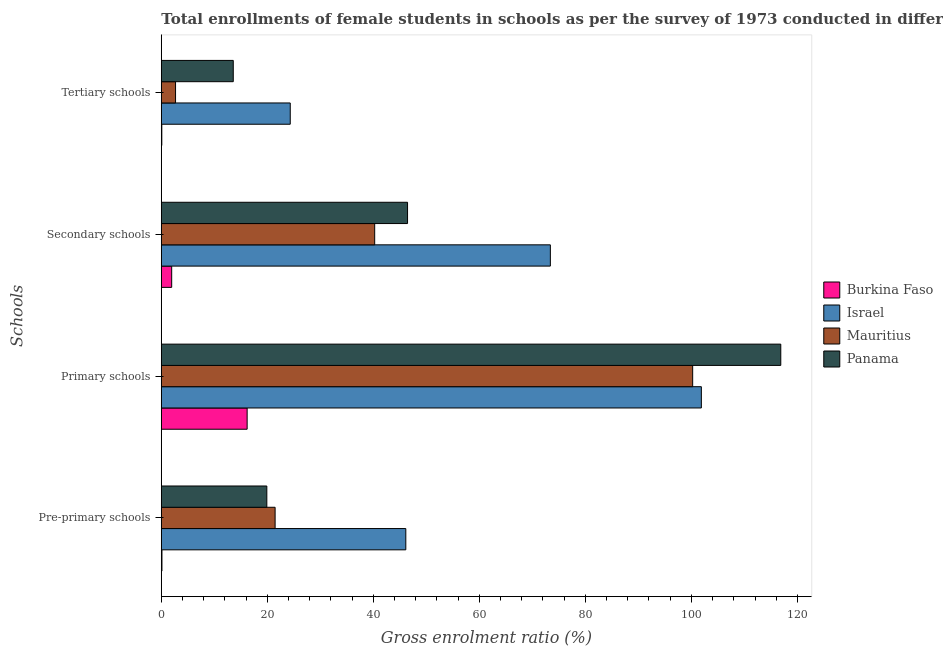How many different coloured bars are there?
Your answer should be very brief. 4. How many bars are there on the 2nd tick from the top?
Your answer should be very brief. 4. What is the label of the 2nd group of bars from the top?
Keep it short and to the point. Secondary schools. What is the gross enrolment ratio(female) in secondary schools in Mauritius?
Your answer should be compact. 40.25. Across all countries, what is the maximum gross enrolment ratio(female) in pre-primary schools?
Provide a succinct answer. 46.12. Across all countries, what is the minimum gross enrolment ratio(female) in secondary schools?
Provide a succinct answer. 1.96. In which country was the gross enrolment ratio(female) in tertiary schools minimum?
Ensure brevity in your answer.  Burkina Faso. What is the total gross enrolment ratio(female) in primary schools in the graph?
Give a very brief answer. 335.17. What is the difference between the gross enrolment ratio(female) in pre-primary schools in Burkina Faso and that in Panama?
Give a very brief answer. -19.79. What is the difference between the gross enrolment ratio(female) in tertiary schools in Panama and the gross enrolment ratio(female) in primary schools in Mauritius?
Offer a terse response. -86.67. What is the average gross enrolment ratio(female) in pre-primary schools per country?
Your answer should be compact. 21.9. What is the difference between the gross enrolment ratio(female) in pre-primary schools and gross enrolment ratio(female) in tertiary schools in Israel?
Provide a succinct answer. 21.8. What is the ratio of the gross enrolment ratio(female) in tertiary schools in Mauritius to that in Israel?
Make the answer very short. 0.11. Is the gross enrolment ratio(female) in pre-primary schools in Panama less than that in Burkina Faso?
Provide a succinct answer. No. What is the difference between the highest and the second highest gross enrolment ratio(female) in tertiary schools?
Offer a very short reply. 10.75. What is the difference between the highest and the lowest gross enrolment ratio(female) in primary schools?
Keep it short and to the point. 100.67. In how many countries, is the gross enrolment ratio(female) in pre-primary schools greater than the average gross enrolment ratio(female) in pre-primary schools taken over all countries?
Offer a terse response. 1. Is the sum of the gross enrolment ratio(female) in tertiary schools in Israel and Mauritius greater than the maximum gross enrolment ratio(female) in pre-primary schools across all countries?
Your response must be concise. No. Is it the case that in every country, the sum of the gross enrolment ratio(female) in pre-primary schools and gross enrolment ratio(female) in primary schools is greater than the sum of gross enrolment ratio(female) in secondary schools and gross enrolment ratio(female) in tertiary schools?
Give a very brief answer. No. What does the 2nd bar from the top in Primary schools represents?
Provide a succinct answer. Mauritius. What does the 3rd bar from the bottom in Tertiary schools represents?
Provide a short and direct response. Mauritius. Is it the case that in every country, the sum of the gross enrolment ratio(female) in pre-primary schools and gross enrolment ratio(female) in primary schools is greater than the gross enrolment ratio(female) in secondary schools?
Ensure brevity in your answer.  Yes. Are all the bars in the graph horizontal?
Provide a short and direct response. Yes. How many countries are there in the graph?
Provide a short and direct response. 4. What is the difference between two consecutive major ticks on the X-axis?
Your response must be concise. 20. Are the values on the major ticks of X-axis written in scientific E-notation?
Offer a very short reply. No. Does the graph contain grids?
Offer a very short reply. No. Where does the legend appear in the graph?
Provide a short and direct response. Center right. What is the title of the graph?
Ensure brevity in your answer.  Total enrollments of female students in schools as per the survey of 1973 conducted in different countries. What is the label or title of the Y-axis?
Make the answer very short. Schools. What is the Gross enrolment ratio (%) in Burkina Faso in Pre-primary schools?
Your answer should be very brief. 0.12. What is the Gross enrolment ratio (%) of Israel in Pre-primary schools?
Ensure brevity in your answer.  46.12. What is the Gross enrolment ratio (%) in Mauritius in Pre-primary schools?
Your answer should be very brief. 21.47. What is the Gross enrolment ratio (%) in Panama in Pre-primary schools?
Provide a succinct answer. 19.91. What is the Gross enrolment ratio (%) in Burkina Faso in Primary schools?
Give a very brief answer. 16.19. What is the Gross enrolment ratio (%) of Israel in Primary schools?
Your answer should be very brief. 101.88. What is the Gross enrolment ratio (%) in Mauritius in Primary schools?
Provide a succinct answer. 100.24. What is the Gross enrolment ratio (%) of Panama in Primary schools?
Offer a terse response. 116.86. What is the Gross enrolment ratio (%) of Burkina Faso in Secondary schools?
Your answer should be very brief. 1.96. What is the Gross enrolment ratio (%) in Israel in Secondary schools?
Provide a short and direct response. 73.39. What is the Gross enrolment ratio (%) of Mauritius in Secondary schools?
Offer a very short reply. 40.25. What is the Gross enrolment ratio (%) in Panama in Secondary schools?
Offer a very short reply. 46.45. What is the Gross enrolment ratio (%) of Burkina Faso in Tertiary schools?
Your response must be concise. 0.09. What is the Gross enrolment ratio (%) of Israel in Tertiary schools?
Give a very brief answer. 24.32. What is the Gross enrolment ratio (%) in Mauritius in Tertiary schools?
Your answer should be compact. 2.69. What is the Gross enrolment ratio (%) of Panama in Tertiary schools?
Provide a short and direct response. 13.57. Across all Schools, what is the maximum Gross enrolment ratio (%) of Burkina Faso?
Your answer should be very brief. 16.19. Across all Schools, what is the maximum Gross enrolment ratio (%) in Israel?
Ensure brevity in your answer.  101.88. Across all Schools, what is the maximum Gross enrolment ratio (%) in Mauritius?
Offer a terse response. 100.24. Across all Schools, what is the maximum Gross enrolment ratio (%) of Panama?
Provide a succinct answer. 116.86. Across all Schools, what is the minimum Gross enrolment ratio (%) in Burkina Faso?
Give a very brief answer. 0.09. Across all Schools, what is the minimum Gross enrolment ratio (%) in Israel?
Your response must be concise. 24.32. Across all Schools, what is the minimum Gross enrolment ratio (%) in Mauritius?
Give a very brief answer. 2.69. Across all Schools, what is the minimum Gross enrolment ratio (%) in Panama?
Provide a succinct answer. 13.57. What is the total Gross enrolment ratio (%) of Burkina Faso in the graph?
Your answer should be very brief. 18.36. What is the total Gross enrolment ratio (%) of Israel in the graph?
Your answer should be compact. 245.72. What is the total Gross enrolment ratio (%) of Mauritius in the graph?
Give a very brief answer. 164.65. What is the total Gross enrolment ratio (%) in Panama in the graph?
Provide a succinct answer. 196.79. What is the difference between the Gross enrolment ratio (%) of Burkina Faso in Pre-primary schools and that in Primary schools?
Provide a succinct answer. -16.07. What is the difference between the Gross enrolment ratio (%) of Israel in Pre-primary schools and that in Primary schools?
Your response must be concise. -55.76. What is the difference between the Gross enrolment ratio (%) in Mauritius in Pre-primary schools and that in Primary schools?
Ensure brevity in your answer.  -78.77. What is the difference between the Gross enrolment ratio (%) of Panama in Pre-primary schools and that in Primary schools?
Your answer should be compact. -96.96. What is the difference between the Gross enrolment ratio (%) in Burkina Faso in Pre-primary schools and that in Secondary schools?
Give a very brief answer. -1.84. What is the difference between the Gross enrolment ratio (%) of Israel in Pre-primary schools and that in Secondary schools?
Your answer should be very brief. -27.27. What is the difference between the Gross enrolment ratio (%) of Mauritius in Pre-primary schools and that in Secondary schools?
Ensure brevity in your answer.  -18.78. What is the difference between the Gross enrolment ratio (%) of Panama in Pre-primary schools and that in Secondary schools?
Keep it short and to the point. -26.55. What is the difference between the Gross enrolment ratio (%) in Burkina Faso in Pre-primary schools and that in Tertiary schools?
Offer a terse response. 0.02. What is the difference between the Gross enrolment ratio (%) of Israel in Pre-primary schools and that in Tertiary schools?
Your response must be concise. 21.8. What is the difference between the Gross enrolment ratio (%) of Mauritius in Pre-primary schools and that in Tertiary schools?
Ensure brevity in your answer.  18.78. What is the difference between the Gross enrolment ratio (%) in Panama in Pre-primary schools and that in Tertiary schools?
Make the answer very short. 6.33. What is the difference between the Gross enrolment ratio (%) of Burkina Faso in Primary schools and that in Secondary schools?
Give a very brief answer. 14.23. What is the difference between the Gross enrolment ratio (%) of Israel in Primary schools and that in Secondary schools?
Provide a short and direct response. 28.49. What is the difference between the Gross enrolment ratio (%) of Mauritius in Primary schools and that in Secondary schools?
Ensure brevity in your answer.  59.99. What is the difference between the Gross enrolment ratio (%) of Panama in Primary schools and that in Secondary schools?
Your answer should be very brief. 70.41. What is the difference between the Gross enrolment ratio (%) of Burkina Faso in Primary schools and that in Tertiary schools?
Keep it short and to the point. 16.1. What is the difference between the Gross enrolment ratio (%) in Israel in Primary schools and that in Tertiary schools?
Make the answer very short. 77.56. What is the difference between the Gross enrolment ratio (%) of Mauritius in Primary schools and that in Tertiary schools?
Your answer should be very brief. 97.56. What is the difference between the Gross enrolment ratio (%) of Panama in Primary schools and that in Tertiary schools?
Keep it short and to the point. 103.29. What is the difference between the Gross enrolment ratio (%) of Burkina Faso in Secondary schools and that in Tertiary schools?
Give a very brief answer. 1.86. What is the difference between the Gross enrolment ratio (%) of Israel in Secondary schools and that in Tertiary schools?
Provide a short and direct response. 49.07. What is the difference between the Gross enrolment ratio (%) in Mauritius in Secondary schools and that in Tertiary schools?
Ensure brevity in your answer.  37.57. What is the difference between the Gross enrolment ratio (%) in Panama in Secondary schools and that in Tertiary schools?
Give a very brief answer. 32.88. What is the difference between the Gross enrolment ratio (%) in Burkina Faso in Pre-primary schools and the Gross enrolment ratio (%) in Israel in Primary schools?
Ensure brevity in your answer.  -101.76. What is the difference between the Gross enrolment ratio (%) of Burkina Faso in Pre-primary schools and the Gross enrolment ratio (%) of Mauritius in Primary schools?
Ensure brevity in your answer.  -100.12. What is the difference between the Gross enrolment ratio (%) of Burkina Faso in Pre-primary schools and the Gross enrolment ratio (%) of Panama in Primary schools?
Ensure brevity in your answer.  -116.74. What is the difference between the Gross enrolment ratio (%) in Israel in Pre-primary schools and the Gross enrolment ratio (%) in Mauritius in Primary schools?
Make the answer very short. -54.12. What is the difference between the Gross enrolment ratio (%) of Israel in Pre-primary schools and the Gross enrolment ratio (%) of Panama in Primary schools?
Keep it short and to the point. -70.74. What is the difference between the Gross enrolment ratio (%) of Mauritius in Pre-primary schools and the Gross enrolment ratio (%) of Panama in Primary schools?
Ensure brevity in your answer.  -95.4. What is the difference between the Gross enrolment ratio (%) in Burkina Faso in Pre-primary schools and the Gross enrolment ratio (%) in Israel in Secondary schools?
Your answer should be very brief. -73.27. What is the difference between the Gross enrolment ratio (%) of Burkina Faso in Pre-primary schools and the Gross enrolment ratio (%) of Mauritius in Secondary schools?
Your answer should be very brief. -40.13. What is the difference between the Gross enrolment ratio (%) in Burkina Faso in Pre-primary schools and the Gross enrolment ratio (%) in Panama in Secondary schools?
Provide a short and direct response. -46.33. What is the difference between the Gross enrolment ratio (%) of Israel in Pre-primary schools and the Gross enrolment ratio (%) of Mauritius in Secondary schools?
Offer a terse response. 5.87. What is the difference between the Gross enrolment ratio (%) in Israel in Pre-primary schools and the Gross enrolment ratio (%) in Panama in Secondary schools?
Offer a terse response. -0.33. What is the difference between the Gross enrolment ratio (%) in Mauritius in Pre-primary schools and the Gross enrolment ratio (%) in Panama in Secondary schools?
Offer a terse response. -24.98. What is the difference between the Gross enrolment ratio (%) of Burkina Faso in Pre-primary schools and the Gross enrolment ratio (%) of Israel in Tertiary schools?
Your answer should be compact. -24.2. What is the difference between the Gross enrolment ratio (%) in Burkina Faso in Pre-primary schools and the Gross enrolment ratio (%) in Mauritius in Tertiary schools?
Offer a very short reply. -2.57. What is the difference between the Gross enrolment ratio (%) in Burkina Faso in Pre-primary schools and the Gross enrolment ratio (%) in Panama in Tertiary schools?
Your response must be concise. -13.45. What is the difference between the Gross enrolment ratio (%) in Israel in Pre-primary schools and the Gross enrolment ratio (%) in Mauritius in Tertiary schools?
Provide a succinct answer. 43.44. What is the difference between the Gross enrolment ratio (%) in Israel in Pre-primary schools and the Gross enrolment ratio (%) in Panama in Tertiary schools?
Provide a short and direct response. 32.55. What is the difference between the Gross enrolment ratio (%) of Mauritius in Pre-primary schools and the Gross enrolment ratio (%) of Panama in Tertiary schools?
Provide a succinct answer. 7.89. What is the difference between the Gross enrolment ratio (%) of Burkina Faso in Primary schools and the Gross enrolment ratio (%) of Israel in Secondary schools?
Your answer should be very brief. -57.2. What is the difference between the Gross enrolment ratio (%) of Burkina Faso in Primary schools and the Gross enrolment ratio (%) of Mauritius in Secondary schools?
Offer a terse response. -24.06. What is the difference between the Gross enrolment ratio (%) in Burkina Faso in Primary schools and the Gross enrolment ratio (%) in Panama in Secondary schools?
Your response must be concise. -30.26. What is the difference between the Gross enrolment ratio (%) of Israel in Primary schools and the Gross enrolment ratio (%) of Mauritius in Secondary schools?
Offer a very short reply. 61.63. What is the difference between the Gross enrolment ratio (%) of Israel in Primary schools and the Gross enrolment ratio (%) of Panama in Secondary schools?
Your answer should be very brief. 55.43. What is the difference between the Gross enrolment ratio (%) of Mauritius in Primary schools and the Gross enrolment ratio (%) of Panama in Secondary schools?
Provide a short and direct response. 53.79. What is the difference between the Gross enrolment ratio (%) in Burkina Faso in Primary schools and the Gross enrolment ratio (%) in Israel in Tertiary schools?
Your response must be concise. -8.13. What is the difference between the Gross enrolment ratio (%) of Burkina Faso in Primary schools and the Gross enrolment ratio (%) of Mauritius in Tertiary schools?
Your answer should be compact. 13.51. What is the difference between the Gross enrolment ratio (%) in Burkina Faso in Primary schools and the Gross enrolment ratio (%) in Panama in Tertiary schools?
Offer a very short reply. 2.62. What is the difference between the Gross enrolment ratio (%) of Israel in Primary schools and the Gross enrolment ratio (%) of Mauritius in Tertiary schools?
Offer a terse response. 99.19. What is the difference between the Gross enrolment ratio (%) in Israel in Primary schools and the Gross enrolment ratio (%) in Panama in Tertiary schools?
Your response must be concise. 88.3. What is the difference between the Gross enrolment ratio (%) of Mauritius in Primary schools and the Gross enrolment ratio (%) of Panama in Tertiary schools?
Give a very brief answer. 86.67. What is the difference between the Gross enrolment ratio (%) of Burkina Faso in Secondary schools and the Gross enrolment ratio (%) of Israel in Tertiary schools?
Offer a terse response. -22.36. What is the difference between the Gross enrolment ratio (%) of Burkina Faso in Secondary schools and the Gross enrolment ratio (%) of Mauritius in Tertiary schools?
Make the answer very short. -0.73. What is the difference between the Gross enrolment ratio (%) of Burkina Faso in Secondary schools and the Gross enrolment ratio (%) of Panama in Tertiary schools?
Keep it short and to the point. -11.62. What is the difference between the Gross enrolment ratio (%) of Israel in Secondary schools and the Gross enrolment ratio (%) of Mauritius in Tertiary schools?
Offer a terse response. 70.71. What is the difference between the Gross enrolment ratio (%) in Israel in Secondary schools and the Gross enrolment ratio (%) in Panama in Tertiary schools?
Keep it short and to the point. 59.82. What is the difference between the Gross enrolment ratio (%) of Mauritius in Secondary schools and the Gross enrolment ratio (%) of Panama in Tertiary schools?
Give a very brief answer. 26.68. What is the average Gross enrolment ratio (%) of Burkina Faso per Schools?
Make the answer very short. 4.59. What is the average Gross enrolment ratio (%) of Israel per Schools?
Make the answer very short. 61.43. What is the average Gross enrolment ratio (%) in Mauritius per Schools?
Offer a very short reply. 41.16. What is the average Gross enrolment ratio (%) in Panama per Schools?
Ensure brevity in your answer.  49.2. What is the difference between the Gross enrolment ratio (%) in Burkina Faso and Gross enrolment ratio (%) in Israel in Pre-primary schools?
Provide a short and direct response. -46. What is the difference between the Gross enrolment ratio (%) in Burkina Faso and Gross enrolment ratio (%) in Mauritius in Pre-primary schools?
Your response must be concise. -21.35. What is the difference between the Gross enrolment ratio (%) in Burkina Faso and Gross enrolment ratio (%) in Panama in Pre-primary schools?
Your answer should be very brief. -19.79. What is the difference between the Gross enrolment ratio (%) of Israel and Gross enrolment ratio (%) of Mauritius in Pre-primary schools?
Offer a very short reply. 24.66. What is the difference between the Gross enrolment ratio (%) of Israel and Gross enrolment ratio (%) of Panama in Pre-primary schools?
Provide a succinct answer. 26.22. What is the difference between the Gross enrolment ratio (%) in Mauritius and Gross enrolment ratio (%) in Panama in Pre-primary schools?
Keep it short and to the point. 1.56. What is the difference between the Gross enrolment ratio (%) of Burkina Faso and Gross enrolment ratio (%) of Israel in Primary schools?
Your answer should be compact. -85.69. What is the difference between the Gross enrolment ratio (%) in Burkina Faso and Gross enrolment ratio (%) in Mauritius in Primary schools?
Your answer should be compact. -84.05. What is the difference between the Gross enrolment ratio (%) in Burkina Faso and Gross enrolment ratio (%) in Panama in Primary schools?
Provide a short and direct response. -100.67. What is the difference between the Gross enrolment ratio (%) of Israel and Gross enrolment ratio (%) of Mauritius in Primary schools?
Ensure brevity in your answer.  1.64. What is the difference between the Gross enrolment ratio (%) in Israel and Gross enrolment ratio (%) in Panama in Primary schools?
Provide a succinct answer. -14.98. What is the difference between the Gross enrolment ratio (%) of Mauritius and Gross enrolment ratio (%) of Panama in Primary schools?
Provide a short and direct response. -16.62. What is the difference between the Gross enrolment ratio (%) of Burkina Faso and Gross enrolment ratio (%) of Israel in Secondary schools?
Give a very brief answer. -71.43. What is the difference between the Gross enrolment ratio (%) in Burkina Faso and Gross enrolment ratio (%) in Mauritius in Secondary schools?
Give a very brief answer. -38.29. What is the difference between the Gross enrolment ratio (%) in Burkina Faso and Gross enrolment ratio (%) in Panama in Secondary schools?
Your answer should be very brief. -44.49. What is the difference between the Gross enrolment ratio (%) of Israel and Gross enrolment ratio (%) of Mauritius in Secondary schools?
Provide a succinct answer. 33.14. What is the difference between the Gross enrolment ratio (%) of Israel and Gross enrolment ratio (%) of Panama in Secondary schools?
Keep it short and to the point. 26.94. What is the difference between the Gross enrolment ratio (%) in Mauritius and Gross enrolment ratio (%) in Panama in Secondary schools?
Keep it short and to the point. -6.2. What is the difference between the Gross enrolment ratio (%) of Burkina Faso and Gross enrolment ratio (%) of Israel in Tertiary schools?
Your response must be concise. -24.23. What is the difference between the Gross enrolment ratio (%) of Burkina Faso and Gross enrolment ratio (%) of Mauritius in Tertiary schools?
Offer a very short reply. -2.59. What is the difference between the Gross enrolment ratio (%) in Burkina Faso and Gross enrolment ratio (%) in Panama in Tertiary schools?
Keep it short and to the point. -13.48. What is the difference between the Gross enrolment ratio (%) of Israel and Gross enrolment ratio (%) of Mauritius in Tertiary schools?
Offer a terse response. 21.64. What is the difference between the Gross enrolment ratio (%) in Israel and Gross enrolment ratio (%) in Panama in Tertiary schools?
Make the answer very short. 10.75. What is the difference between the Gross enrolment ratio (%) of Mauritius and Gross enrolment ratio (%) of Panama in Tertiary schools?
Offer a very short reply. -10.89. What is the ratio of the Gross enrolment ratio (%) in Burkina Faso in Pre-primary schools to that in Primary schools?
Your answer should be very brief. 0.01. What is the ratio of the Gross enrolment ratio (%) in Israel in Pre-primary schools to that in Primary schools?
Your answer should be compact. 0.45. What is the ratio of the Gross enrolment ratio (%) of Mauritius in Pre-primary schools to that in Primary schools?
Ensure brevity in your answer.  0.21. What is the ratio of the Gross enrolment ratio (%) of Panama in Pre-primary schools to that in Primary schools?
Your answer should be very brief. 0.17. What is the ratio of the Gross enrolment ratio (%) in Burkina Faso in Pre-primary schools to that in Secondary schools?
Give a very brief answer. 0.06. What is the ratio of the Gross enrolment ratio (%) of Israel in Pre-primary schools to that in Secondary schools?
Keep it short and to the point. 0.63. What is the ratio of the Gross enrolment ratio (%) in Mauritius in Pre-primary schools to that in Secondary schools?
Provide a succinct answer. 0.53. What is the ratio of the Gross enrolment ratio (%) of Panama in Pre-primary schools to that in Secondary schools?
Ensure brevity in your answer.  0.43. What is the ratio of the Gross enrolment ratio (%) of Burkina Faso in Pre-primary schools to that in Tertiary schools?
Offer a terse response. 1.26. What is the ratio of the Gross enrolment ratio (%) of Israel in Pre-primary schools to that in Tertiary schools?
Give a very brief answer. 1.9. What is the ratio of the Gross enrolment ratio (%) of Mauritius in Pre-primary schools to that in Tertiary schools?
Make the answer very short. 8. What is the ratio of the Gross enrolment ratio (%) of Panama in Pre-primary schools to that in Tertiary schools?
Offer a terse response. 1.47. What is the ratio of the Gross enrolment ratio (%) of Burkina Faso in Primary schools to that in Secondary schools?
Make the answer very short. 8.27. What is the ratio of the Gross enrolment ratio (%) of Israel in Primary schools to that in Secondary schools?
Your answer should be compact. 1.39. What is the ratio of the Gross enrolment ratio (%) of Mauritius in Primary schools to that in Secondary schools?
Your answer should be very brief. 2.49. What is the ratio of the Gross enrolment ratio (%) of Panama in Primary schools to that in Secondary schools?
Offer a very short reply. 2.52. What is the ratio of the Gross enrolment ratio (%) in Burkina Faso in Primary schools to that in Tertiary schools?
Your response must be concise. 170.98. What is the ratio of the Gross enrolment ratio (%) in Israel in Primary schools to that in Tertiary schools?
Provide a succinct answer. 4.19. What is the ratio of the Gross enrolment ratio (%) of Mauritius in Primary schools to that in Tertiary schools?
Your answer should be very brief. 37.33. What is the ratio of the Gross enrolment ratio (%) of Panama in Primary schools to that in Tertiary schools?
Offer a terse response. 8.61. What is the ratio of the Gross enrolment ratio (%) of Burkina Faso in Secondary schools to that in Tertiary schools?
Provide a short and direct response. 20.67. What is the ratio of the Gross enrolment ratio (%) of Israel in Secondary schools to that in Tertiary schools?
Keep it short and to the point. 3.02. What is the ratio of the Gross enrolment ratio (%) in Mauritius in Secondary schools to that in Tertiary schools?
Offer a terse response. 14.99. What is the ratio of the Gross enrolment ratio (%) of Panama in Secondary schools to that in Tertiary schools?
Provide a succinct answer. 3.42. What is the difference between the highest and the second highest Gross enrolment ratio (%) in Burkina Faso?
Provide a short and direct response. 14.23. What is the difference between the highest and the second highest Gross enrolment ratio (%) in Israel?
Your response must be concise. 28.49. What is the difference between the highest and the second highest Gross enrolment ratio (%) of Mauritius?
Your answer should be very brief. 59.99. What is the difference between the highest and the second highest Gross enrolment ratio (%) in Panama?
Offer a terse response. 70.41. What is the difference between the highest and the lowest Gross enrolment ratio (%) of Burkina Faso?
Offer a terse response. 16.1. What is the difference between the highest and the lowest Gross enrolment ratio (%) in Israel?
Your response must be concise. 77.56. What is the difference between the highest and the lowest Gross enrolment ratio (%) in Mauritius?
Your answer should be very brief. 97.56. What is the difference between the highest and the lowest Gross enrolment ratio (%) of Panama?
Offer a terse response. 103.29. 